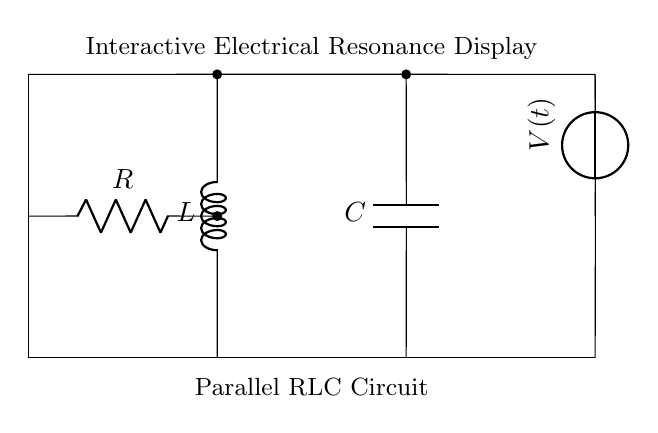What components are present in the circuit? The circuit contains a resistor, inductor, and capacitor, as indicated by the symbols R, L, and C in the diagram.
Answer: Resistor, Inductor, Capacitor What is the connection type of the components? The components (R, L, and C) are connected in parallel, as indicated by the way their leads connect directly across the voltage source.
Answer: Parallel What does the voltage source represent in this circuit? The voltage source, labeled as V(t), provides the time-varying electrical potential that is essential for analyzing the circuit's behavior over time.
Answer: Time-varying voltage What does the 'R' symbolize? The 'R' in the circuit diagram represents the resistor, which is used to limit the current flowing through the circuit.
Answer: Resistor How does the inductor behave at resonance? At resonance, the inductive and capacitive reactances cancel each other out, resulting in maximum current through the circuit and minimal impedance.
Answer: Maximum current What is the significance of the voltage labeled V(t)? V(t) signifies that the voltage across the circuit is a function of time, indicating that it may change dynamically, which is crucial for understanding resonance behavior.
Answer: Time-dependent voltage function What is the function of the capacitor in this circuit? The capacitor (C) stores electrical energy and releases it, influencing the frequency response and helping to achieve resonance in the parallel RLC circuit.
Answer: Stores electrical energy 